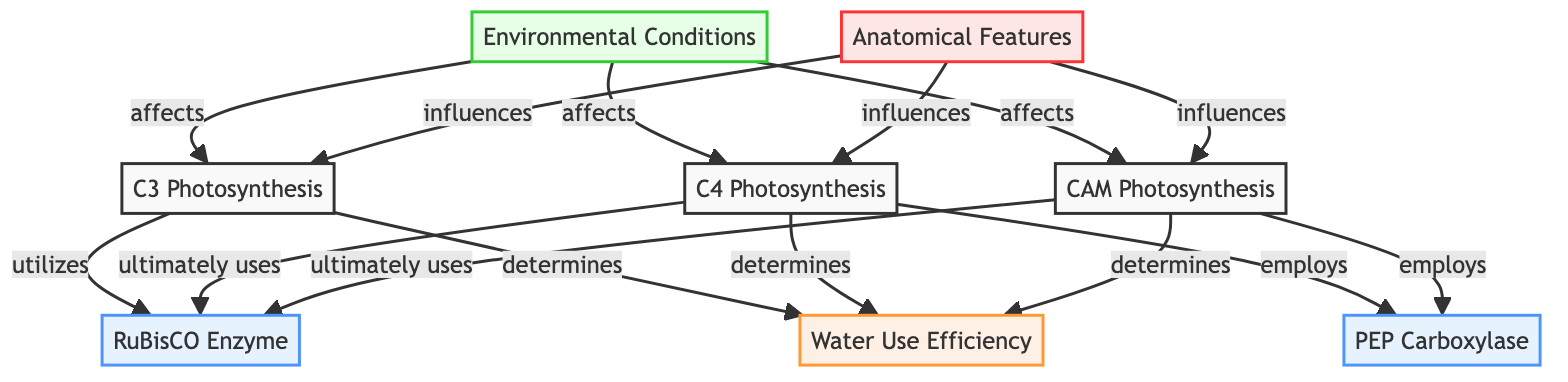What type of enzyme is utilized by C3 photosynthesis? According to the diagram, C3 photosynthesis utilizes the RuBisCO enzyme directly as indicated by the arrow connecting C3 and RuBisCO.
Answer: RuBisCO Which photosynthesis type employs PEP carboxylase? The diagram shows that both C4 and CAM photosynthesis employ the PEP carboxylase enzyme, as indicated by the arrows leading from C4 and CAM to PEP.
Answer: C4 and CAM How many types of photosynthesis are represented in the diagram? The diagram shows three types of photosynthesis: C3, C4, and CAM, which can be counted as indicated by the three distinct nodes.
Answer: 3 Which type of plant photosynthesis is most influenced by anatomical features? The diagram indicates that anatomical features influence all types of photosynthesis, but there isn't a singular focus on one more than others; each type (C3, C4, and CAM) is linked to anatomical features.
Answer: C3, C4, and CAM What do environmental conditions affect based on the diagram? The diagram specifies that environmental conditions affect all three types of photosynthesis (C3, C4, and CAM) as shown by the connections leading from ENV to each of the three photosynthesis types.
Answer: C3, C4, and CAM Which aspect of plant physiology does WUE represent? From the diagram, Water Use Efficiency (WUE) is determined by all three types of photosynthesis (C3, C4, and CAM) as indicated by the arrows connecting these nodes to WUE.
Answer: Water Use Efficiency What type of relationship exists between environmental conditions and WUE in the diagram? The diagram does not show a direct link from environmental conditions to WUE, therefore it is indirect: environmental conditions affect the efficiency of photosynthesis which in turn determines WUE.
Answer: Indirect relationship Which photosynthesis type is highlighted for utilizing the RuBisCO enzyme? The diagram emphasizes that all three types of photosynthesis utilize the RuBisCO enzyme, but it is particularly notable for C3 since it is the primary enzyme listed for C3.
Answer: C3, C4, and CAM 